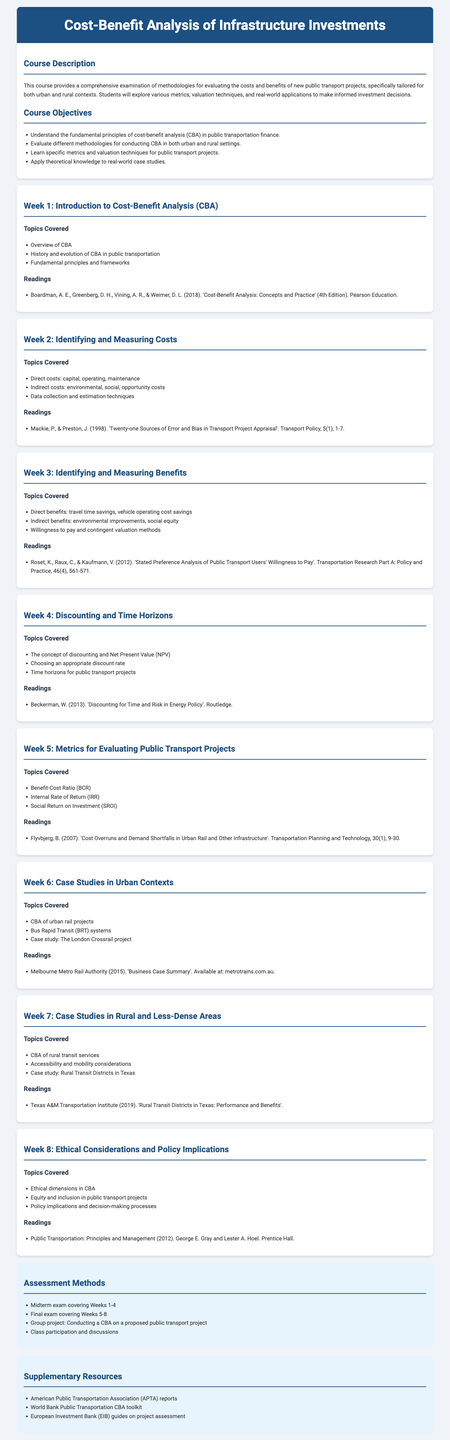what is the title of the course? The title of the course is mentioned at the top of the syllabus.
Answer: Cost-Benefit Analysis of Infrastructure Investments who are the authors of the key reading in Week 1? The authors of the reading in Week 1 are listed in the readings section.
Answer: Boardman, A. E., Greenberg, D. H., Vining, A. R., & Weimer, D. L what is the focus of Week 5? Week 5 focuses on specific metrics for evaluating public transport projects, outlined in the topics covered.
Answer: Metrics for Evaluating Public Transport Projects how many weeks are covered in the syllabus? The total number of weeks can be counted from the week headings in the document.
Answer: Eight what is one of the assessment methods listed? The assessment methods are listed towards the end of the document, and an example can be found among them.
Answer: Final exam covering Weeks 5-8 what is the main theme of Week 8? The main theme of Week 8 is highlighted in the topics covered section.
Answer: Ethical Considerations and Policy Implications which metropolitan area is used as a case study in Week 6? The case study specified in Week 6's topics covered can be found in the designated section.
Answer: The London Crossrail project what metric is evaluated in Week 5? The metrics evaluated in Week 5 are specifically mentioned in the topics covered.
Answer: Benefit-Cost Ratio (BCR) what publication is referenced for readings in Week 2? The specific publication is cited in the reading section for Week 2.
Answer: Twenty-one Sources of Error and Bias in Transport Project Appraisal 